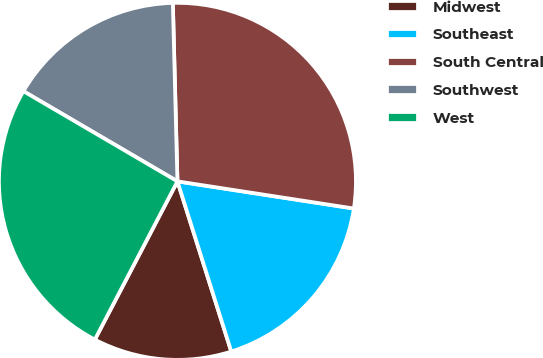<chart> <loc_0><loc_0><loc_500><loc_500><pie_chart><fcel>Midwest<fcel>Southeast<fcel>South Central<fcel>Southwest<fcel>West<nl><fcel>12.53%<fcel>17.69%<fcel>27.84%<fcel>16.16%<fcel>25.77%<nl></chart> 